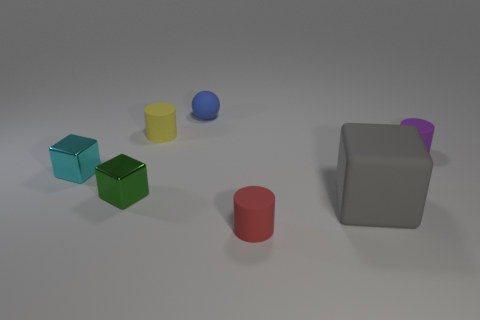Add 2 small blue cylinders. How many objects exist? 9 Subtract all cylinders. How many objects are left? 4 Add 4 green things. How many green things are left? 5 Add 7 cyan shiny cubes. How many cyan shiny cubes exist? 8 Subtract 0 brown cylinders. How many objects are left? 7 Subtract all cyan things. Subtract all tiny yellow cylinders. How many objects are left? 5 